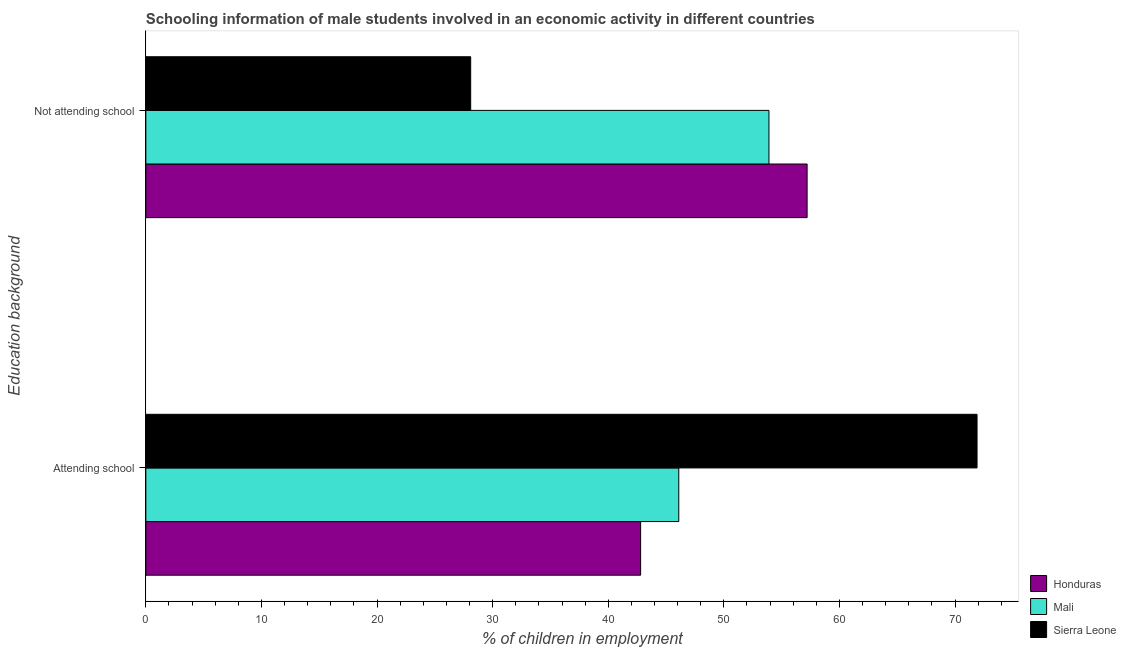How many different coloured bars are there?
Provide a short and direct response. 3. Are the number of bars per tick equal to the number of legend labels?
Provide a succinct answer. Yes. Are the number of bars on each tick of the Y-axis equal?
Provide a succinct answer. Yes. How many bars are there on the 1st tick from the top?
Keep it short and to the point. 3. How many bars are there on the 1st tick from the bottom?
Offer a very short reply. 3. What is the label of the 1st group of bars from the top?
Offer a very short reply. Not attending school. What is the percentage of employed males who are not attending school in Honduras?
Provide a short and direct response. 57.2. Across all countries, what is the maximum percentage of employed males who are not attending school?
Offer a terse response. 57.2. Across all countries, what is the minimum percentage of employed males who are not attending school?
Give a very brief answer. 28.1. In which country was the percentage of employed males who are not attending school maximum?
Give a very brief answer. Honduras. In which country was the percentage of employed males who are attending school minimum?
Ensure brevity in your answer.  Honduras. What is the total percentage of employed males who are not attending school in the graph?
Your answer should be compact. 139.2. What is the difference between the percentage of employed males who are attending school in Mali and that in Honduras?
Your response must be concise. 3.3. What is the difference between the percentage of employed males who are not attending school in Honduras and the percentage of employed males who are attending school in Sierra Leone?
Your answer should be compact. -14.7. What is the average percentage of employed males who are attending school per country?
Make the answer very short. 53.6. What is the difference between the percentage of employed males who are not attending school and percentage of employed males who are attending school in Sierra Leone?
Ensure brevity in your answer.  -43.8. What is the ratio of the percentage of employed males who are attending school in Honduras to that in Sierra Leone?
Make the answer very short. 0.6. Is the percentage of employed males who are attending school in Mali less than that in Honduras?
Your answer should be compact. No. What does the 2nd bar from the top in Attending school represents?
Your response must be concise. Mali. What does the 2nd bar from the bottom in Not attending school represents?
Make the answer very short. Mali. How many bars are there?
Provide a short and direct response. 6. What is the difference between two consecutive major ticks on the X-axis?
Give a very brief answer. 10. Where does the legend appear in the graph?
Offer a terse response. Bottom right. How are the legend labels stacked?
Keep it short and to the point. Vertical. What is the title of the graph?
Your answer should be compact. Schooling information of male students involved in an economic activity in different countries. What is the label or title of the X-axis?
Offer a terse response. % of children in employment. What is the label or title of the Y-axis?
Offer a very short reply. Education background. What is the % of children in employment of Honduras in Attending school?
Provide a succinct answer. 42.8. What is the % of children in employment in Mali in Attending school?
Offer a terse response. 46.1. What is the % of children in employment in Sierra Leone in Attending school?
Your response must be concise. 71.9. What is the % of children in employment in Honduras in Not attending school?
Offer a terse response. 57.2. What is the % of children in employment of Mali in Not attending school?
Provide a succinct answer. 53.9. What is the % of children in employment in Sierra Leone in Not attending school?
Offer a very short reply. 28.1. Across all Education background, what is the maximum % of children in employment of Honduras?
Provide a short and direct response. 57.2. Across all Education background, what is the maximum % of children in employment of Mali?
Make the answer very short. 53.9. Across all Education background, what is the maximum % of children in employment in Sierra Leone?
Your answer should be compact. 71.9. Across all Education background, what is the minimum % of children in employment in Honduras?
Your response must be concise. 42.8. Across all Education background, what is the minimum % of children in employment in Mali?
Provide a short and direct response. 46.1. Across all Education background, what is the minimum % of children in employment in Sierra Leone?
Give a very brief answer. 28.1. What is the total % of children in employment of Honduras in the graph?
Your response must be concise. 100. What is the total % of children in employment in Mali in the graph?
Your answer should be very brief. 100. What is the difference between the % of children in employment in Honduras in Attending school and that in Not attending school?
Make the answer very short. -14.4. What is the difference between the % of children in employment of Mali in Attending school and that in Not attending school?
Offer a terse response. -7.8. What is the difference between the % of children in employment of Sierra Leone in Attending school and that in Not attending school?
Offer a terse response. 43.8. What is the difference between the % of children in employment in Mali in Attending school and the % of children in employment in Sierra Leone in Not attending school?
Your answer should be compact. 18. What is the average % of children in employment of Honduras per Education background?
Give a very brief answer. 50. What is the average % of children in employment in Mali per Education background?
Keep it short and to the point. 50. What is the average % of children in employment of Sierra Leone per Education background?
Ensure brevity in your answer.  50. What is the difference between the % of children in employment in Honduras and % of children in employment in Mali in Attending school?
Make the answer very short. -3.3. What is the difference between the % of children in employment of Honduras and % of children in employment of Sierra Leone in Attending school?
Offer a very short reply. -29.1. What is the difference between the % of children in employment in Mali and % of children in employment in Sierra Leone in Attending school?
Your answer should be very brief. -25.8. What is the difference between the % of children in employment in Honduras and % of children in employment in Sierra Leone in Not attending school?
Keep it short and to the point. 29.1. What is the difference between the % of children in employment in Mali and % of children in employment in Sierra Leone in Not attending school?
Your answer should be very brief. 25.8. What is the ratio of the % of children in employment in Honduras in Attending school to that in Not attending school?
Offer a terse response. 0.75. What is the ratio of the % of children in employment in Mali in Attending school to that in Not attending school?
Offer a terse response. 0.86. What is the ratio of the % of children in employment in Sierra Leone in Attending school to that in Not attending school?
Your response must be concise. 2.56. What is the difference between the highest and the second highest % of children in employment in Honduras?
Offer a very short reply. 14.4. What is the difference between the highest and the second highest % of children in employment in Mali?
Offer a terse response. 7.8. What is the difference between the highest and the second highest % of children in employment of Sierra Leone?
Your response must be concise. 43.8. What is the difference between the highest and the lowest % of children in employment of Sierra Leone?
Your answer should be compact. 43.8. 